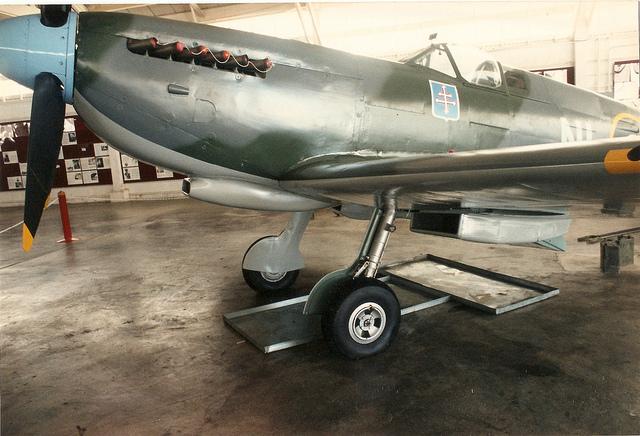What color is this plane?
Answer briefly. Silver. Where is the propeller?
Quick response, please. Front of plane. Is there a propeller on the nose?
Keep it brief. Yes. 